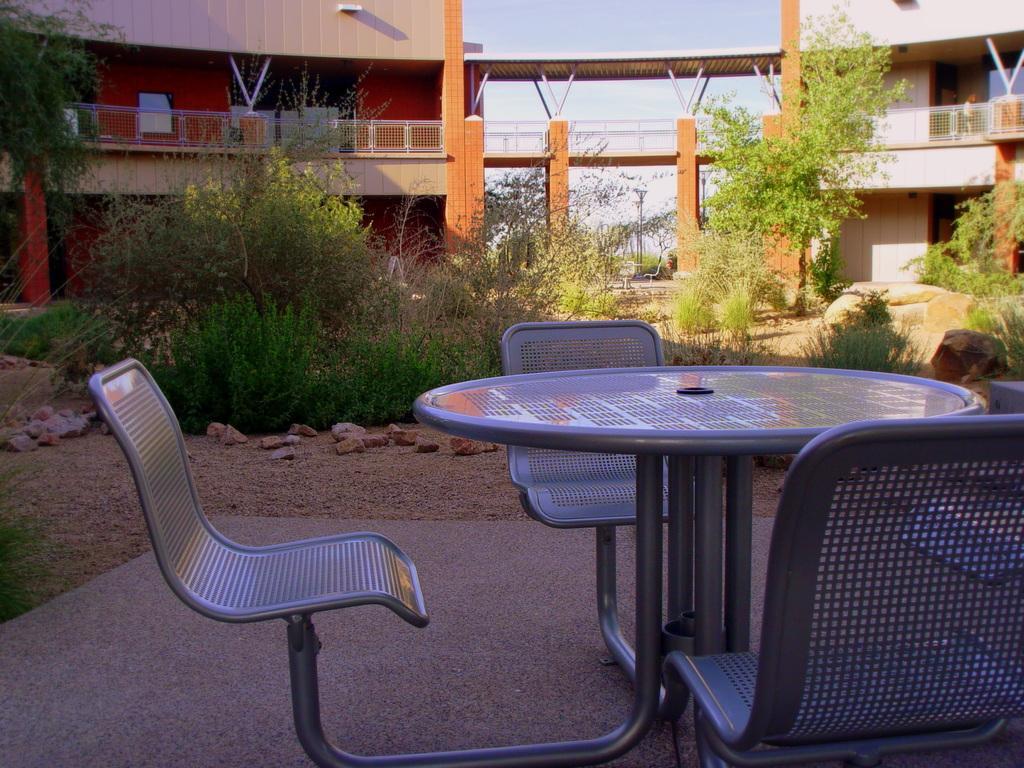Describe this image in one or two sentences. In this image I can see two buildings and a bridge linking these two buildings and in the center of the image I can see some trees and plants, at the top of the image at the bottom of the image I can see a table with three chairs. 